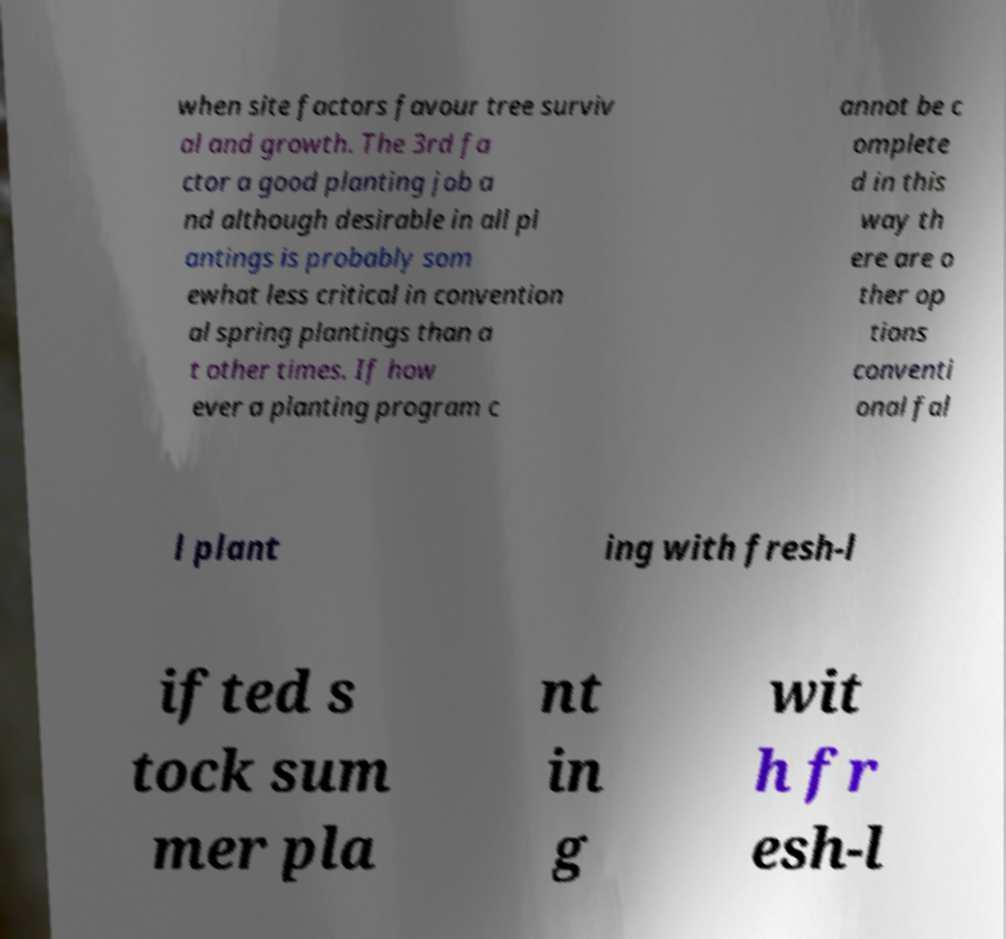For documentation purposes, I need the text within this image transcribed. Could you provide that? when site factors favour tree surviv al and growth. The 3rd fa ctor a good planting job a nd although desirable in all pl antings is probably som ewhat less critical in convention al spring plantings than a t other times. If how ever a planting program c annot be c omplete d in this way th ere are o ther op tions conventi onal fal l plant ing with fresh-l ifted s tock sum mer pla nt in g wit h fr esh-l 